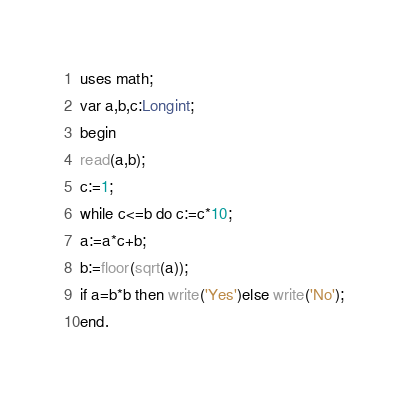<code> <loc_0><loc_0><loc_500><loc_500><_Pascal_>uses math;
var a,b,c:Longint;
begin
read(a,b);
c:=1;
while c<=b do c:=c*10;
a:=a*c+b;
b:=floor(sqrt(a));
if a=b*b then write('Yes')else write('No');
end.
</code> 